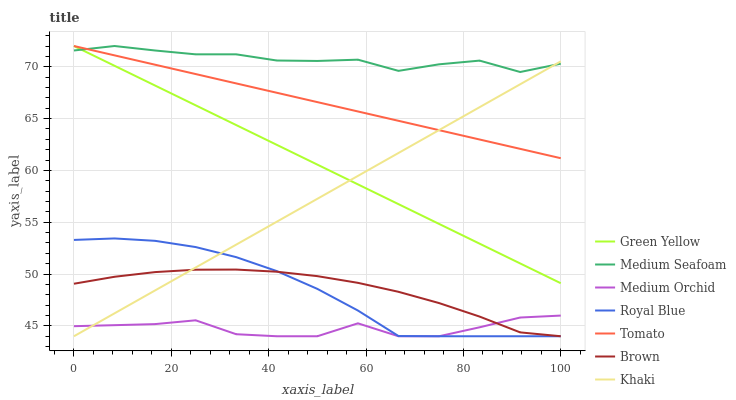Does Medium Orchid have the minimum area under the curve?
Answer yes or no. Yes. Does Medium Seafoam have the maximum area under the curve?
Answer yes or no. Yes. Does Brown have the minimum area under the curve?
Answer yes or no. No. Does Brown have the maximum area under the curve?
Answer yes or no. No. Is Tomato the smoothest?
Answer yes or no. Yes. Is Medium Orchid the roughest?
Answer yes or no. Yes. Is Brown the smoothest?
Answer yes or no. No. Is Brown the roughest?
Answer yes or no. No. Does Brown have the lowest value?
Answer yes or no. Yes. Does Green Yellow have the lowest value?
Answer yes or no. No. Does Medium Seafoam have the highest value?
Answer yes or no. Yes. Does Brown have the highest value?
Answer yes or no. No. Is Royal Blue less than Tomato?
Answer yes or no. Yes. Is Medium Seafoam greater than Brown?
Answer yes or no. Yes. Does Tomato intersect Khaki?
Answer yes or no. Yes. Is Tomato less than Khaki?
Answer yes or no. No. Is Tomato greater than Khaki?
Answer yes or no. No. Does Royal Blue intersect Tomato?
Answer yes or no. No. 